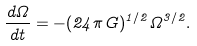<formula> <loc_0><loc_0><loc_500><loc_500>\frac { d \Omega } { d t } = - ( 2 4 \pi G ) ^ { 1 / 2 } \Omega ^ { 3 / 2 } .</formula> 